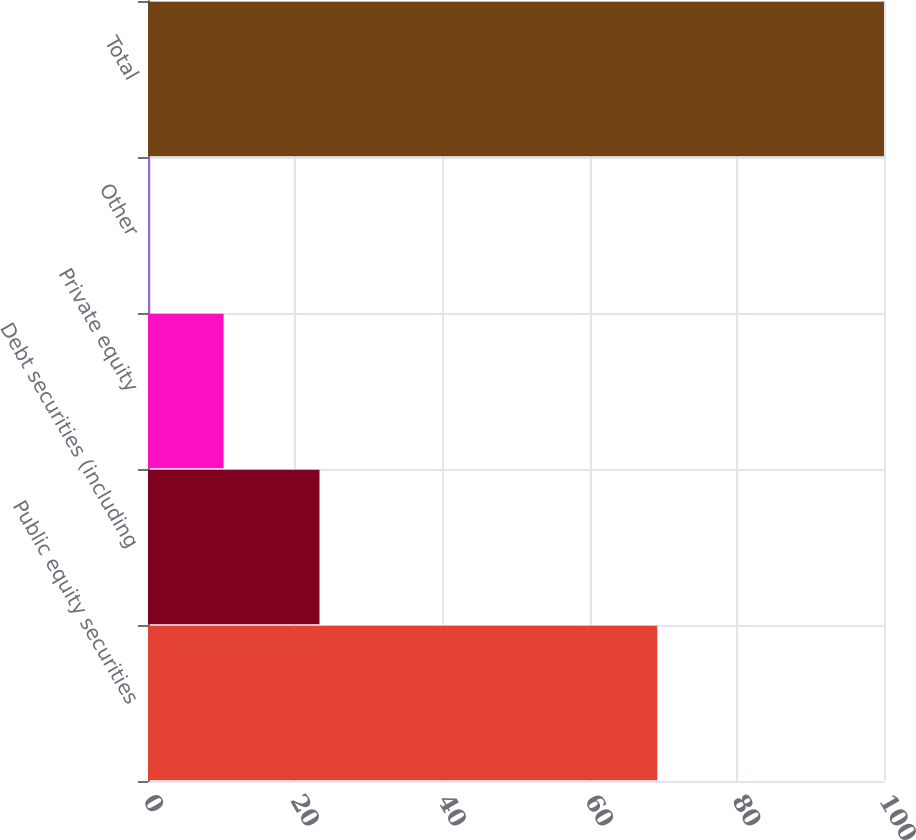Convert chart. <chart><loc_0><loc_0><loc_500><loc_500><bar_chart><fcel>Public equity securities<fcel>Debt securities (including<fcel>Private equity<fcel>Other<fcel>Total<nl><fcel>69.2<fcel>23.3<fcel>10.27<fcel>0.3<fcel>100<nl></chart> 